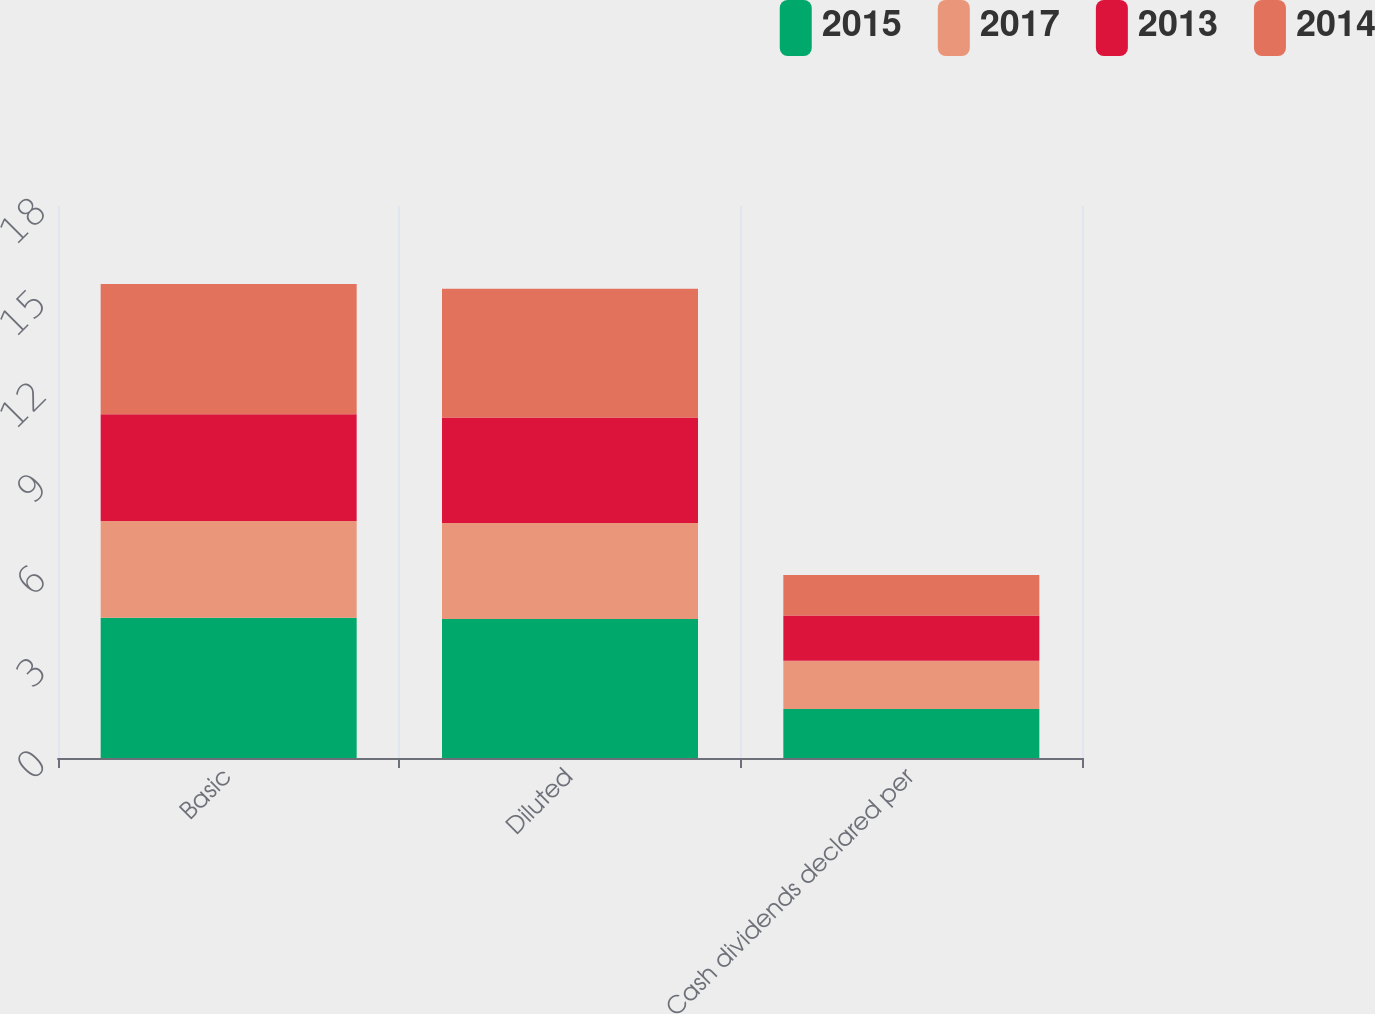Convert chart. <chart><loc_0><loc_0><loc_500><loc_500><stacked_bar_chart><ecel><fcel>Basic<fcel>Diluted<fcel>Cash dividends declared per<nl><fcel>2015<fcel>4.57<fcel>4.53<fcel>1.6<nl><fcel>2017<fcel>3.16<fcel>3.13<fcel>1.57<nl><fcel>2013<fcel>3.48<fcel>3.44<fcel>1.48<nl><fcel>2014<fcel>4.25<fcel>4.2<fcel>1.32<nl></chart> 